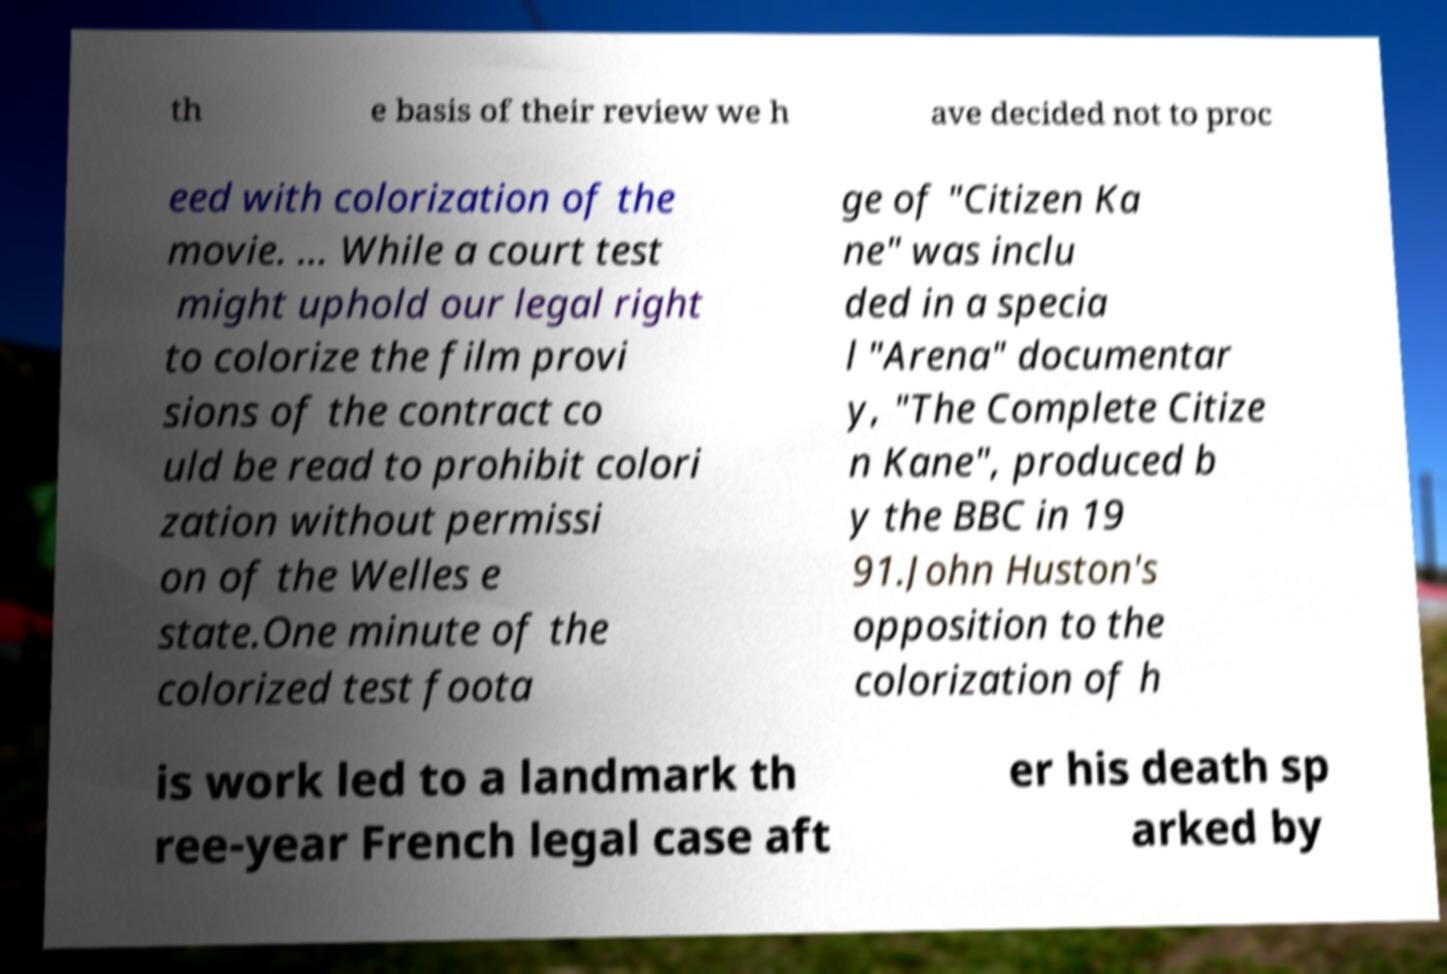Can you read and provide the text displayed in the image?This photo seems to have some interesting text. Can you extract and type it out for me? th e basis of their review we h ave decided not to proc eed with colorization of the movie. … While a court test might uphold our legal right to colorize the film provi sions of the contract co uld be read to prohibit colori zation without permissi on of the Welles e state.One minute of the colorized test foota ge of "Citizen Ka ne" was inclu ded in a specia l "Arena" documentar y, "The Complete Citize n Kane", produced b y the BBC in 19 91.John Huston's opposition to the colorization of h is work led to a landmark th ree-year French legal case aft er his death sp arked by 